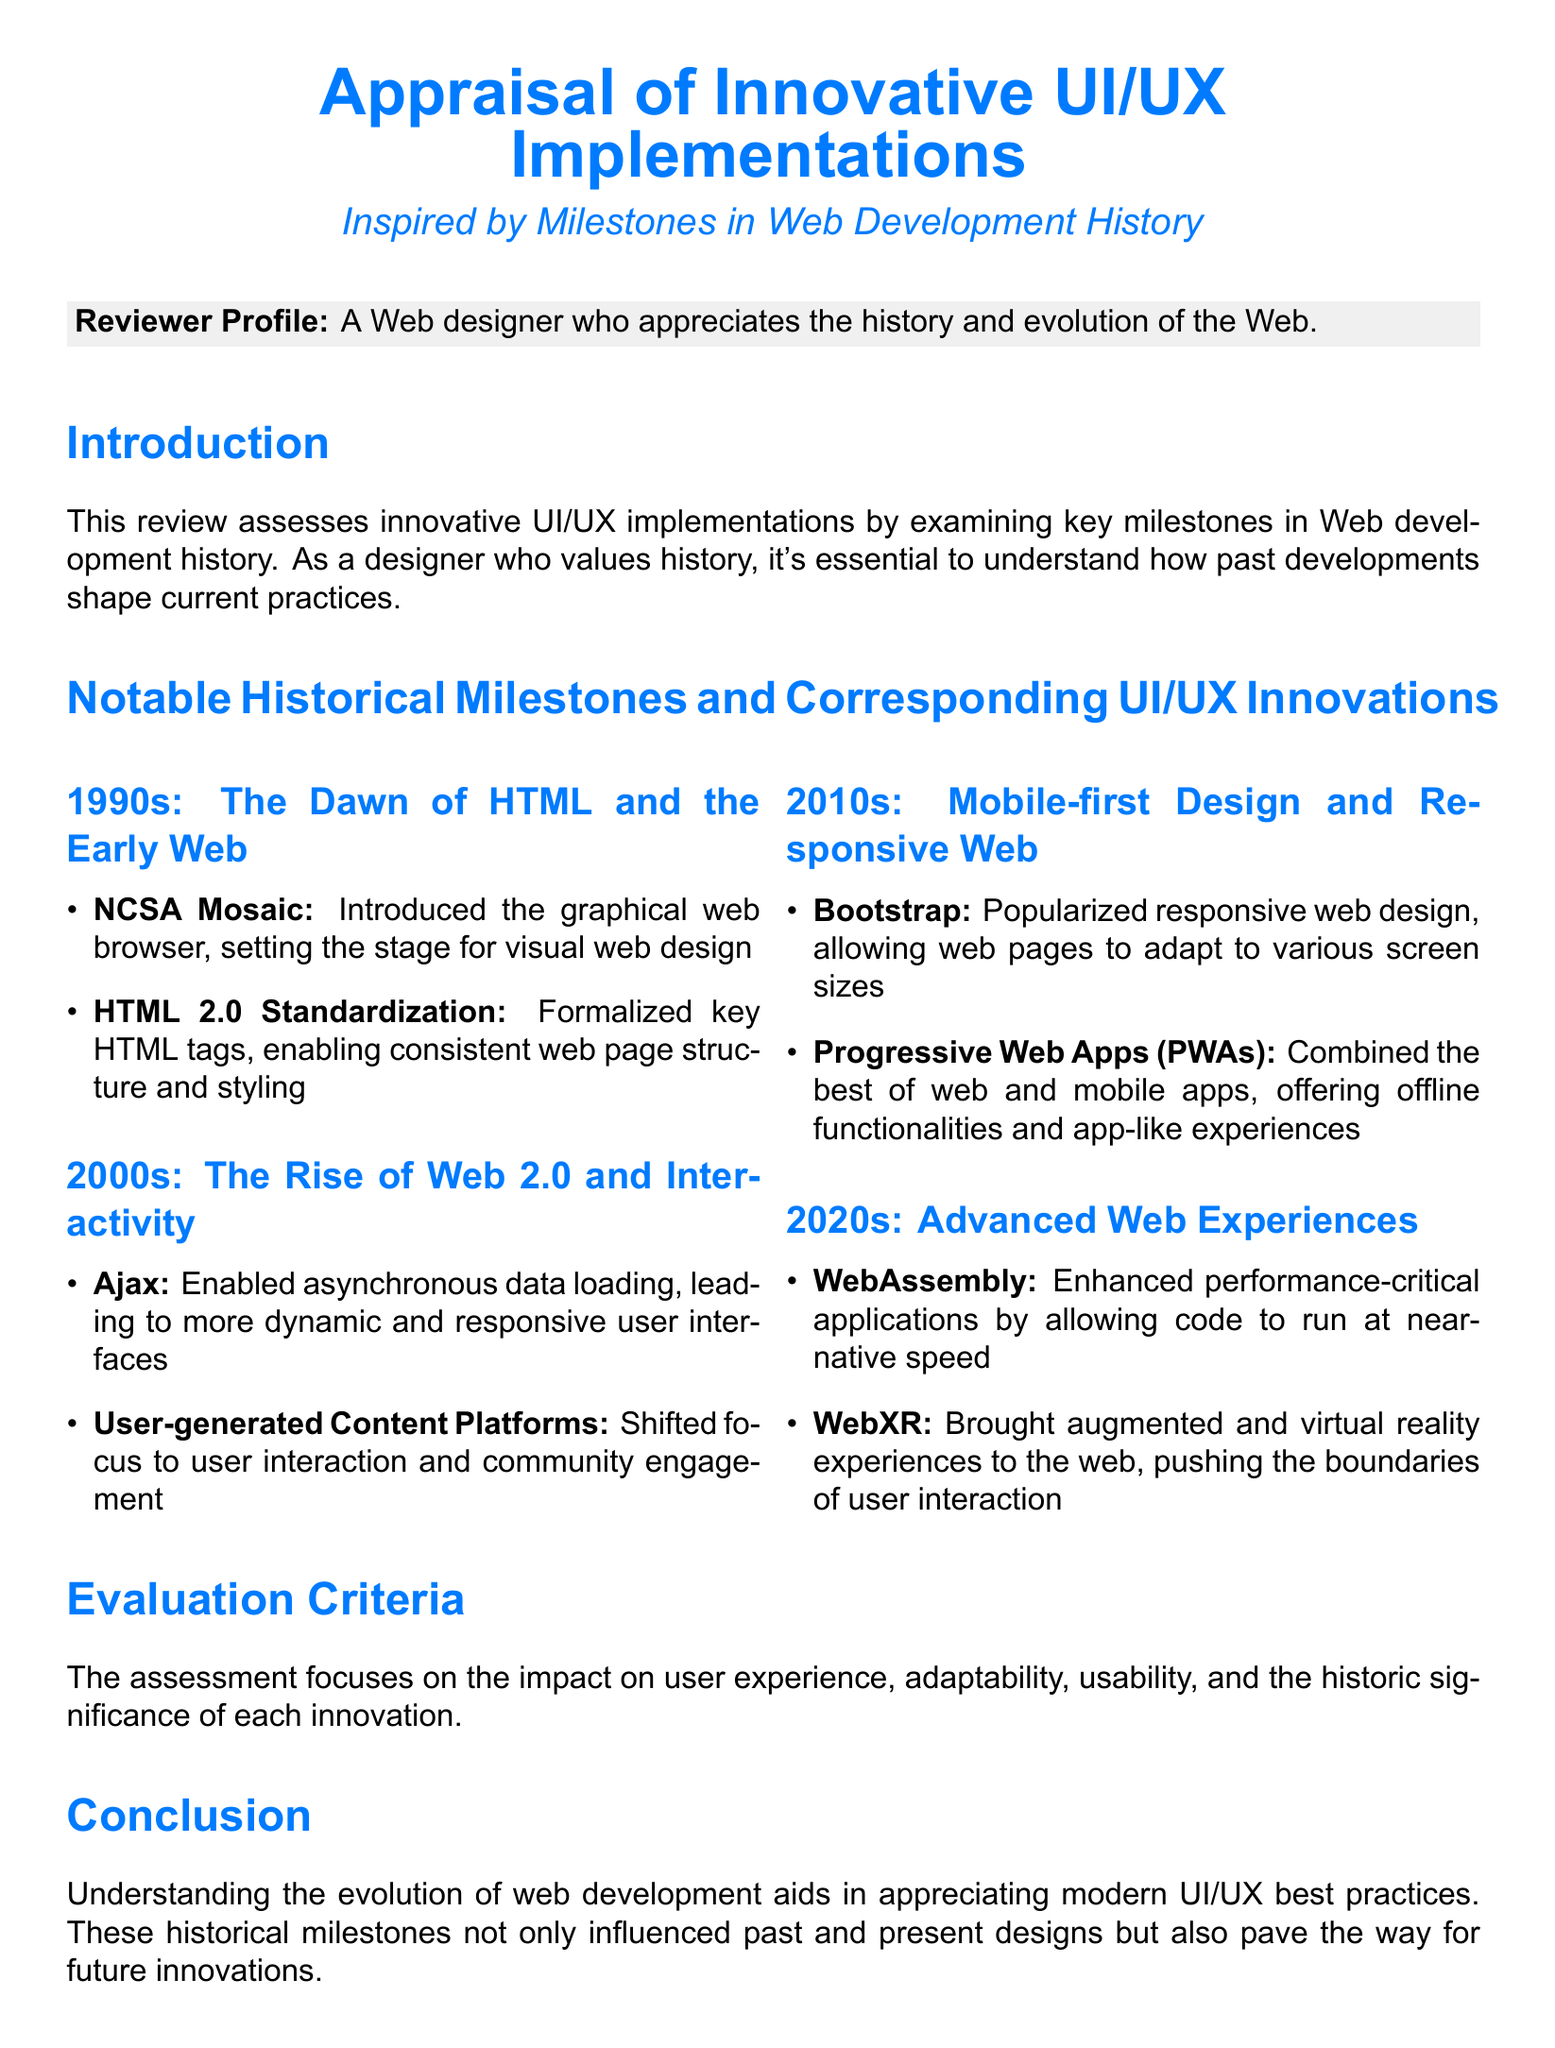What innovative browser introduced the graphical web interface? NCSA Mosaic is mentioned as the browser that set the stage for visual web design in the 1990s.
Answer: NCSA Mosaic What technology allowed for asynchronous data loading in the 2000s? Ajax is noted as the technology that enabled asynchronous data loading, which contributed to more dynamic interfaces.
Answer: Ajax What framework popularized responsive web design in the 2010s? Bootstrap is mentioned as the framework that popularized responsive web design during that decade.
Answer: Bootstrap Which application type combines web and mobile app features in the 2010s? Progressive Web Apps (PWAs) are described as combining web and mobile app features, providing an app-like experience.
Answer: Progressive Web Apps What does WebXR bring to the web in the 2020s? WebXR is noted for bringing augmented and virtual reality experiences to the web.
Answer: Augmented and virtual reality experiences What is the primary focus of the assessment? The assessment focuses on the impact on user experience, adaptability, usability, and historic significance of innovations.
Answer: User experience What is the document's title? The title is explicitly mentioned at the beginning of the document, emphasizing the appraisal of UI/UX implementations.
Answer: Appraisal of Innovative UI/UX Implementations What decade does the document first reference in its historical milestones? The document begins its historical milestones with the 1990s.
Answer: 1990s What is the purpose of the review mentioned in the introduction? The introduction states that the review aims to assess innovative UI/UX implementations by examining key milestones.
Answer: Assess innovative UI/UX implementations 